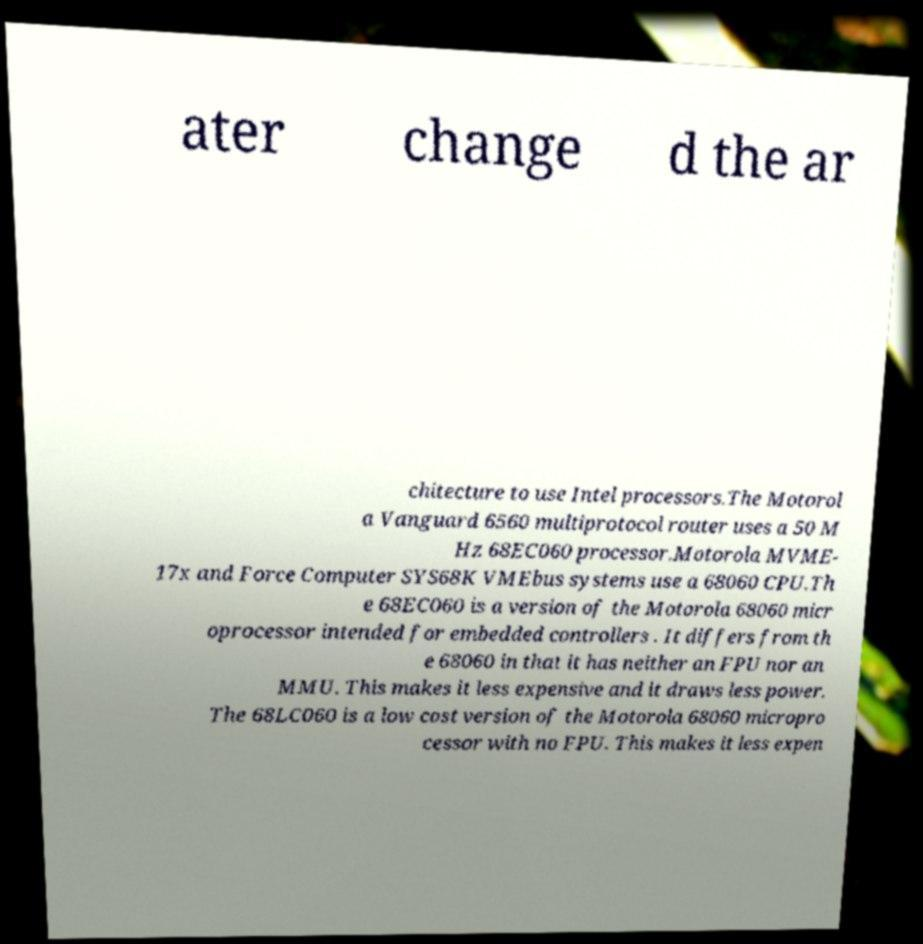There's text embedded in this image that I need extracted. Can you transcribe it verbatim? ater change d the ar chitecture to use Intel processors.The Motorol a Vanguard 6560 multiprotocol router uses a 50 M Hz 68EC060 processor.Motorola MVME- 17x and Force Computer SYS68K VMEbus systems use a 68060 CPU.Th e 68EC060 is a version of the Motorola 68060 micr oprocessor intended for embedded controllers . It differs from th e 68060 in that it has neither an FPU nor an MMU. This makes it less expensive and it draws less power. The 68LC060 is a low cost version of the Motorola 68060 micropro cessor with no FPU. This makes it less expen 